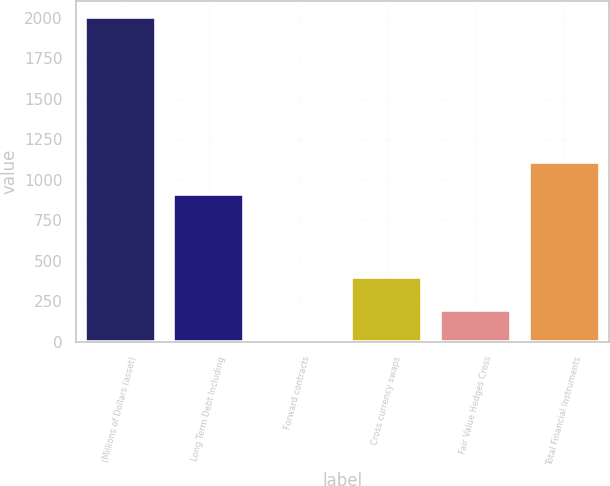Convert chart. <chart><loc_0><loc_0><loc_500><loc_500><bar_chart><fcel>(Millions of Dollars (asset)<fcel>Long Term Debt Including<fcel>Forward contracts<fcel>Cross currency swaps<fcel>Fair Value Hedges Cross<fcel>Total Financial Instruments<nl><fcel>2005<fcel>912.3<fcel>0.1<fcel>401.08<fcel>200.59<fcel>1112.79<nl></chart> 